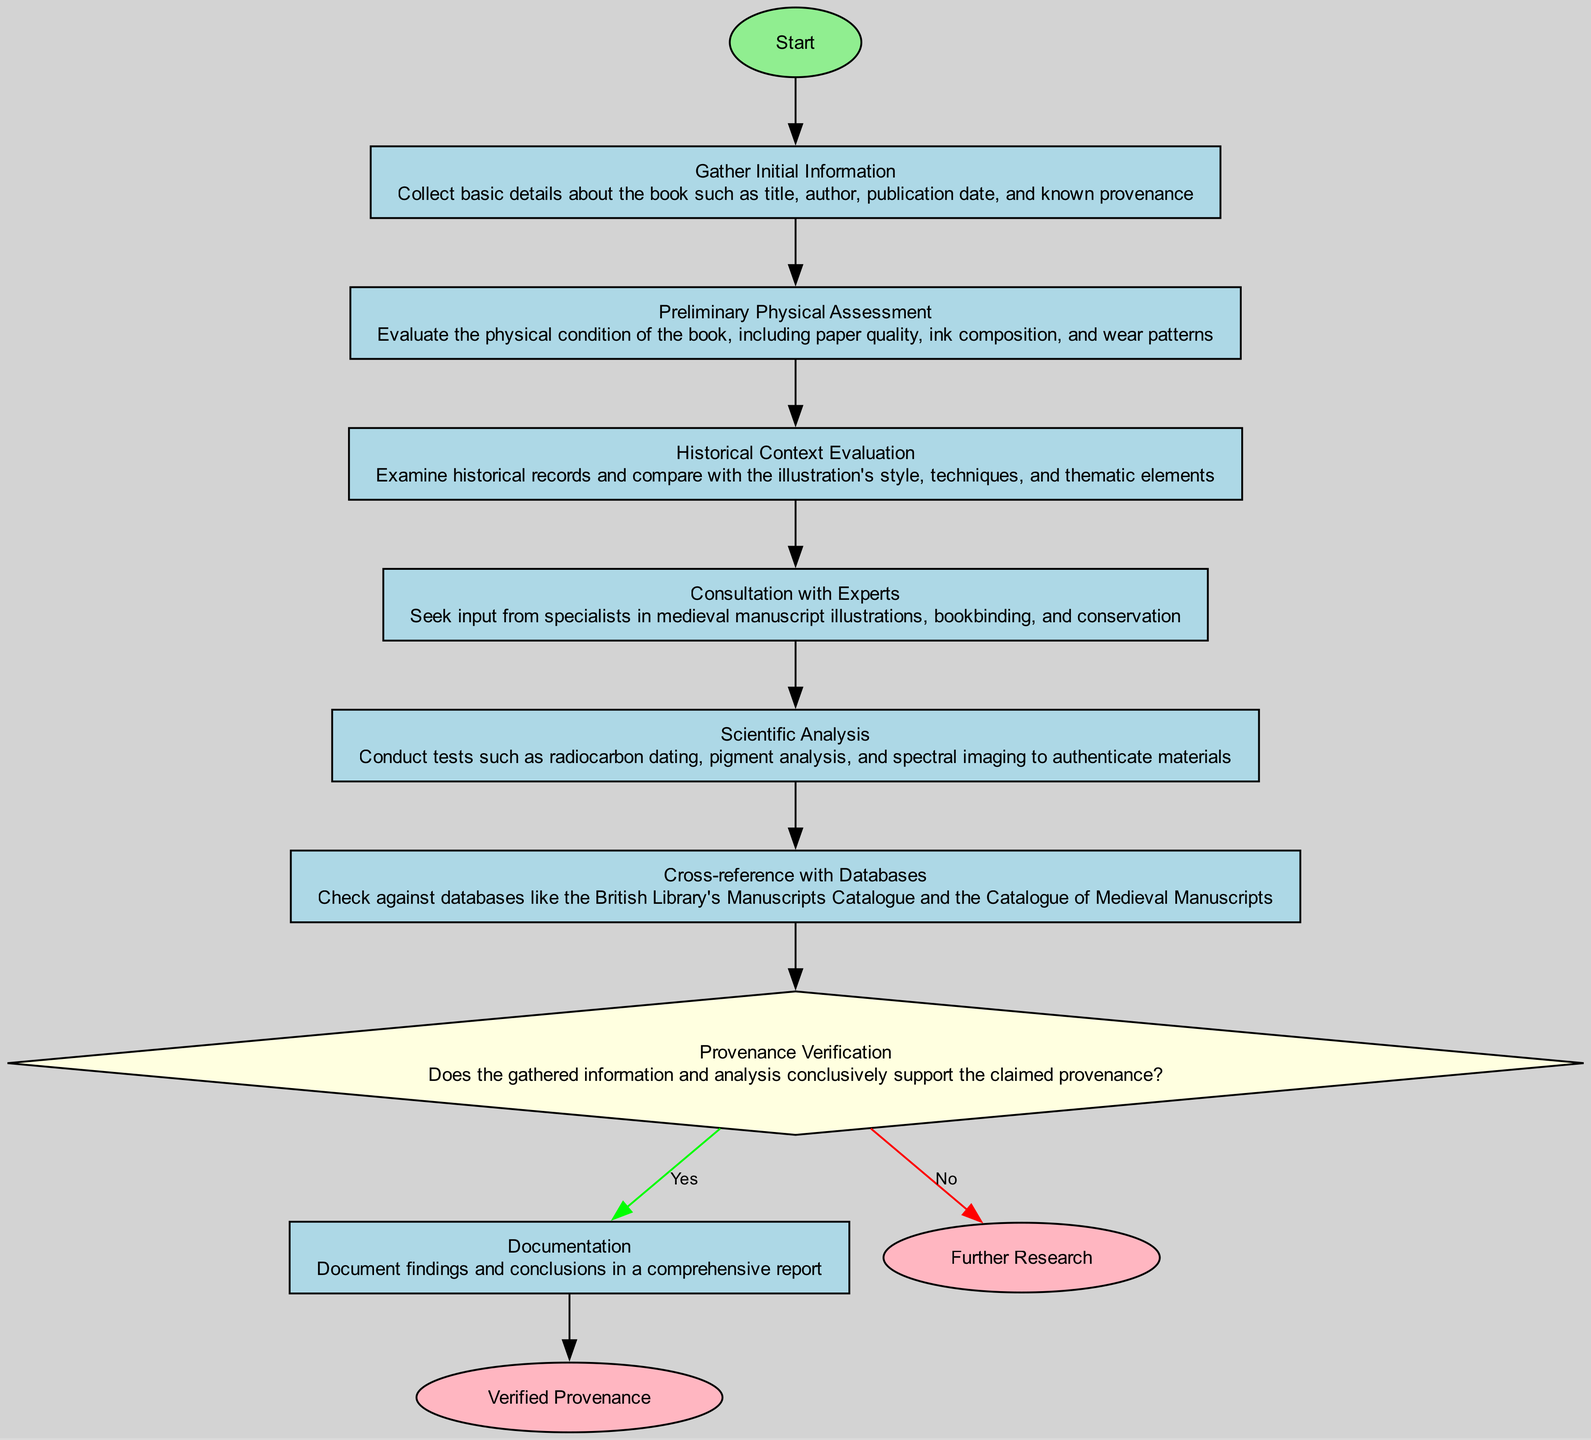What is the first step in this process? The diagram shows that the first step, represented by node '1', is labeled "Start." It indicates the initiation of the process.
Answer: Start How many processes are there in the flowchart? By counting the nodes of type 'process' in the diagram, there are a total of 7 processes (nodes 2, 3, 4, 5, 6, 7, and 9).
Answer: 7 What is the decision point in the flowchart? The decision point is represented by node '8', labeled "Provenance Verification," where the flow branches based on outcomes.
Answer: Provenance Verification If the provenance is verified, what is the next step? From the decision point '8', if the answer is "Yes," the next step leads to node '9', which is "Documentation." Thus, the flow continues to document findings.
Answer: Documentation What steps are taken before consulting with experts? According to the flow of the diagram, before reaching the "Consultation with Experts" node (node 5), the steps taken are "Gather Initial Information" (node 2), "Preliminary Physical Assessment" (node 3), and "Historical Context Evaluation" (node 4).
Answer: Gather Initial Information, Preliminary Physical Assessment, Historical Context Evaluation How is scientific analysis conducted in relation to the previous steps? The "Scientific Analysis" node (node 6) follows after the "Consultation with Experts" (node 5) indicating this analysis is completed after expert consultation. Thus, the scientific tests depend on the prior input and discussions.
Answer: After consultation with experts What happens if the provenance cannot be authenticated? If the provenance cannot be authenticated, as indicated at decision point '8', it leads to node '11' labeled "Further Research," meaning more investigation is necessary without a validation of provenance.
Answer: Further Research What type of nodes are present in the flowchart? The flowchart consists of three types of nodes: start nodes (1), process nodes (2 to 7, 9), decision nodes (8), and end nodes (10, 11).
Answer: Start, process, decision, end What is the final outcome if provenance is authenticated? The final outcome if the provenance is authenticated is indicated by node '10', which states "Verified Provenance," confirming the authenticity of the provenance.
Answer: Verified Provenance 